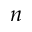<formula> <loc_0><loc_0><loc_500><loc_500>n</formula> 